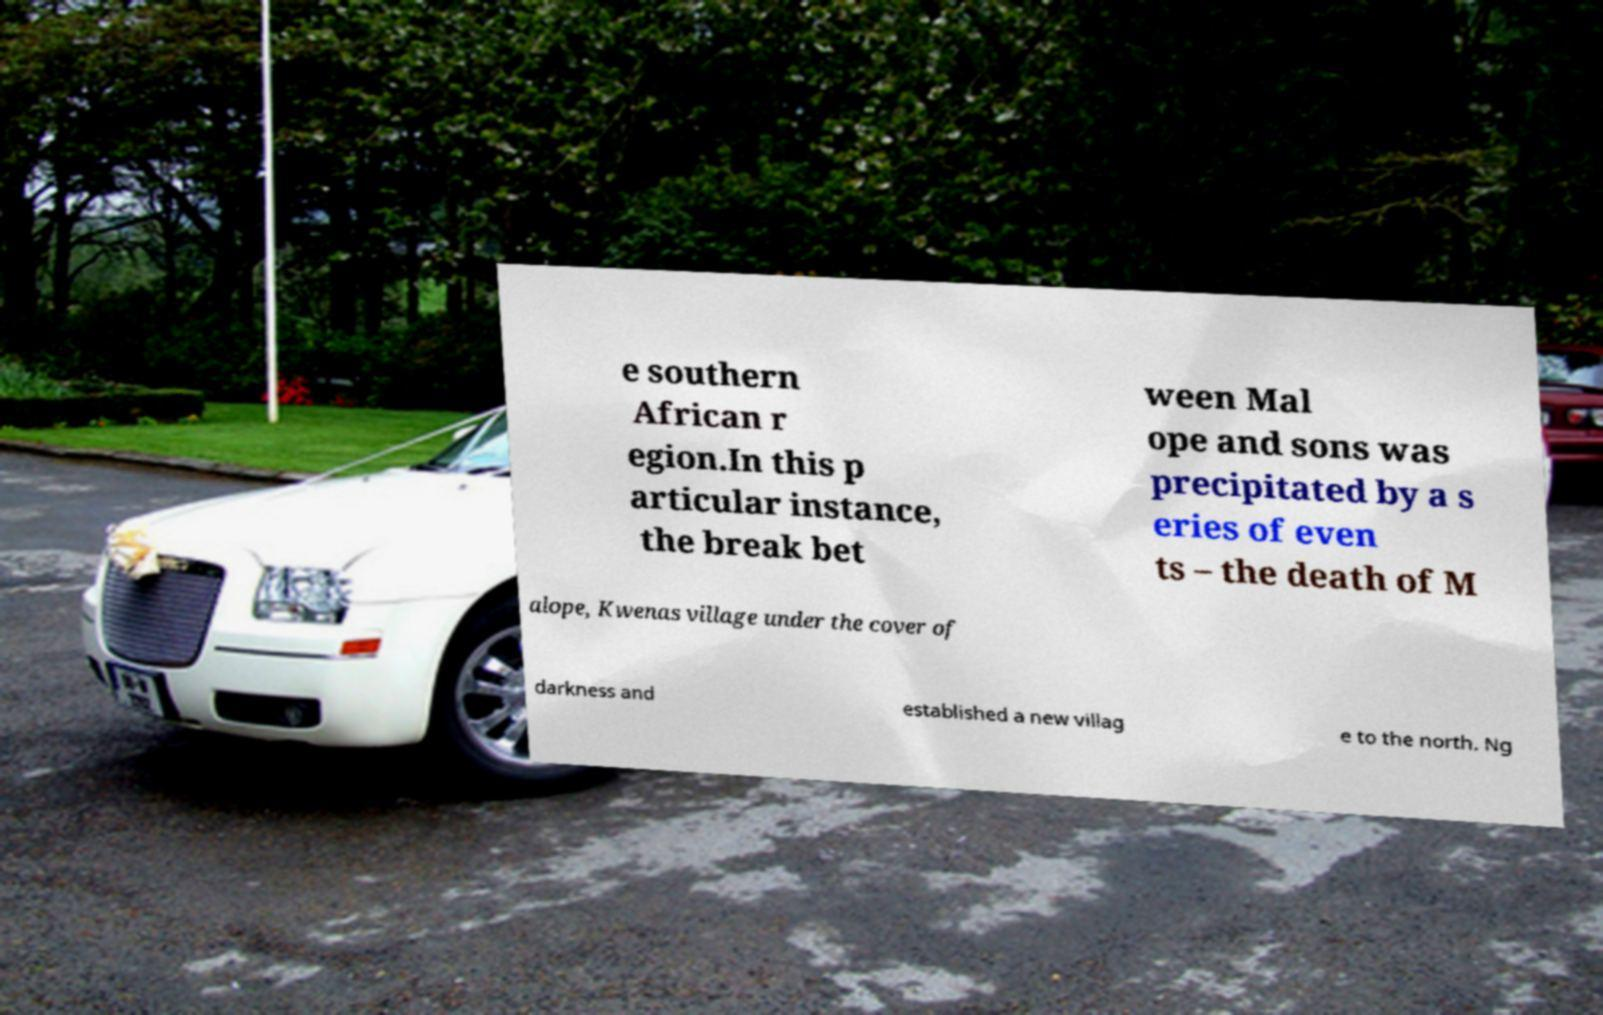Could you extract and type out the text from this image? e southern African r egion.In this p articular instance, the break bet ween Mal ope and sons was precipitated by a s eries of even ts – the death of M alope, Kwenas village under the cover of darkness and established a new villag e to the north. Ng 